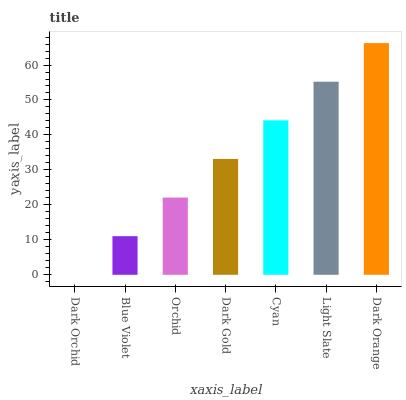Is Dark Orchid the minimum?
Answer yes or no. Yes. Is Dark Orange the maximum?
Answer yes or no. Yes. Is Blue Violet the minimum?
Answer yes or no. No. Is Blue Violet the maximum?
Answer yes or no. No. Is Blue Violet greater than Dark Orchid?
Answer yes or no. Yes. Is Dark Orchid less than Blue Violet?
Answer yes or no. Yes. Is Dark Orchid greater than Blue Violet?
Answer yes or no. No. Is Blue Violet less than Dark Orchid?
Answer yes or no. No. Is Dark Gold the high median?
Answer yes or no. Yes. Is Dark Gold the low median?
Answer yes or no. Yes. Is Blue Violet the high median?
Answer yes or no. No. Is Blue Violet the low median?
Answer yes or no. No. 